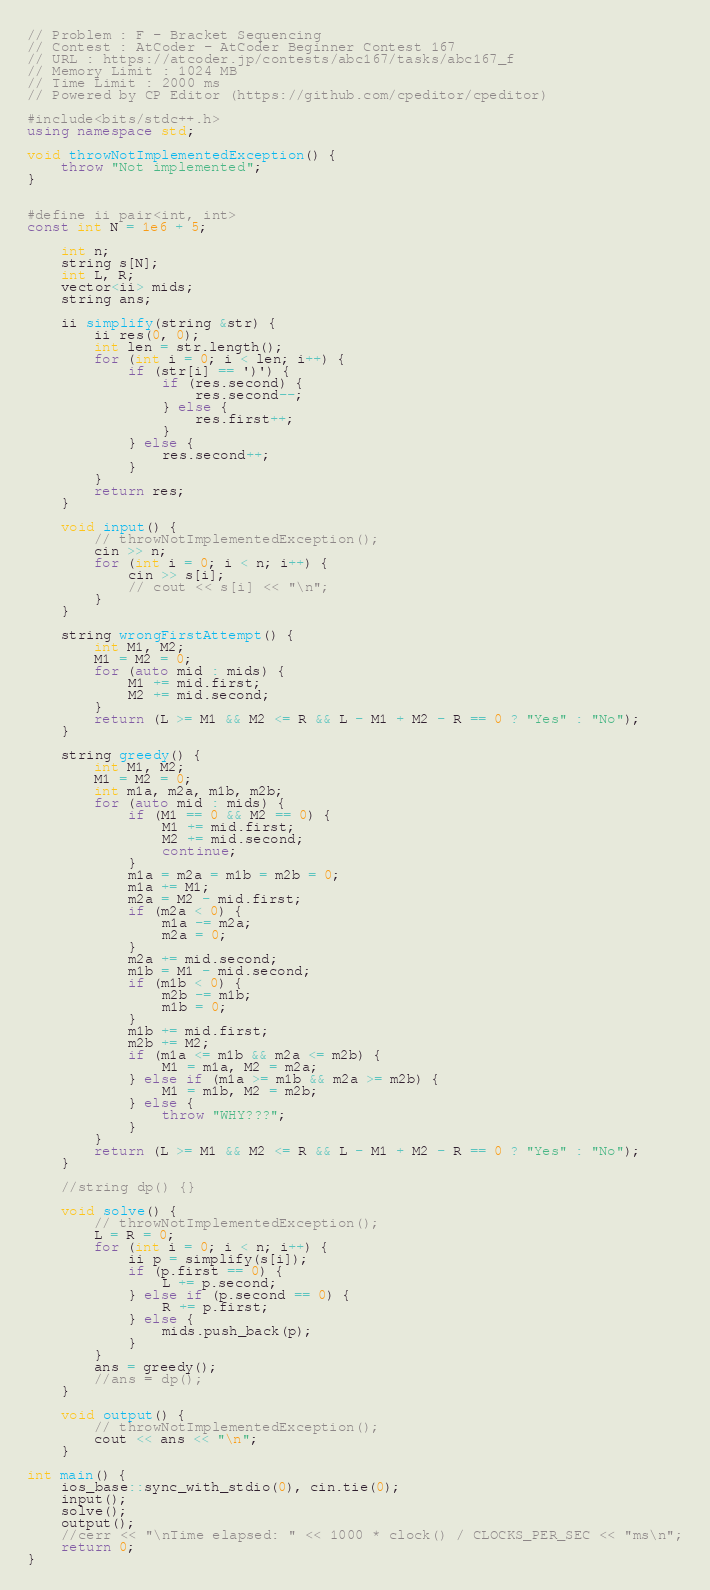Convert code to text. <code><loc_0><loc_0><loc_500><loc_500><_C++_>
// Problem : F - Bracket Sequencing
// Contest : AtCoder - AtCoder Beginner Contest 167
// URL : https://atcoder.jp/contests/abc167/tasks/abc167_f
// Memory Limit : 1024 MB
// Time Limit : 2000 ms
// Powered by CP Editor (https://github.com/cpeditor/cpeditor)

#include<bits/stdc++.h>
using namespace std;

void throwNotImplementedException() {
	throw "Not implemented";
}
	

#define ii pair<int, int>
const int N = 1e6 + 5;

	int n;
	string s[N];
	int L, R;
	vector<ii> mids;
	string ans;

	ii simplify(string &str) {
		ii res(0, 0);
		int len = str.length();
		for (int i = 0; i < len; i++) {
			if (str[i] == ')') {
				if (res.second) {
					res.second--;
				} else {
					res.first++;
				}
			} else {
				res.second++;
			}
		}
		return res;
	}

	void input() {
		// throwNotImplementedException();
		cin >> n;
		for (int i = 0; i < n; i++) {
			cin >> s[i];
			// cout << s[i] << "\n";
		}
	} 
	
	string wrongFirstAttempt() {
		int M1, M2;
		M1 = M2 = 0;
		for (auto mid : mids) {
			M1 += mid.first;
			M2 += mid.second;
		}
		return (L >= M1 && M2 <= R && L - M1 + M2 - R == 0 ? "Yes" : "No");
	}

	string greedy() {
		int M1, M2;
		M1 = M2 = 0;
		int m1a, m2a, m1b, m2b;
		for (auto mid : mids) {
			if (M1 == 0 && M2 == 0) {
				M1 += mid.first;
				M2 += mid.second;
				continue;
			}
			m1a = m2a = m1b = m2b = 0;
			m1a += M1;
			m2a = M2 - mid.first;
			if (m2a < 0) {
				m1a -= m2a;
				m2a = 0;
			}
			m2a += mid.second;
			m1b = M1 - mid.second;
			if (m1b < 0) {
				m2b -= m1b;
				m1b = 0;
			}
			m1b += mid.first;
			m2b += M2;
			if (m1a <= m1b && m2a <= m2b) {
				M1 = m1a, M2 = m2a;
			} else if (m1a >= m1b && m2a >= m2b) {
				M1 = m1b, M2 = m2b;
			} else {
				throw "WHY???";
			}
		}
		return (L >= M1 && M2 <= R && L - M1 + M2 - R == 0 ? "Yes" : "No");
	}

	//string dp() {}
	
	void solve() {
		// throwNotImplementedException();
		L = R = 0;
		for (int i = 0; i < n; i++) {
			ii p = simplify(s[i]);
			if (p.first == 0) {
				L += p.second;
			} else if (p.second == 0) {
				R += p.first;
			} else {
				mids.push_back(p);
			}
		}
		ans = greedy();
		//ans = dp();
	}
	
	void output() {
		// throwNotImplementedException();
		cout << ans << "\n";
	}

int main() {
	ios_base::sync_with_stdio(0), cin.tie(0);
	input();
	solve();
	output();
	//cerr << "\nTime elapsed: " << 1000 * clock() / CLOCKS_PER_SEC << "ms\n";
	return 0;
}
</code> 